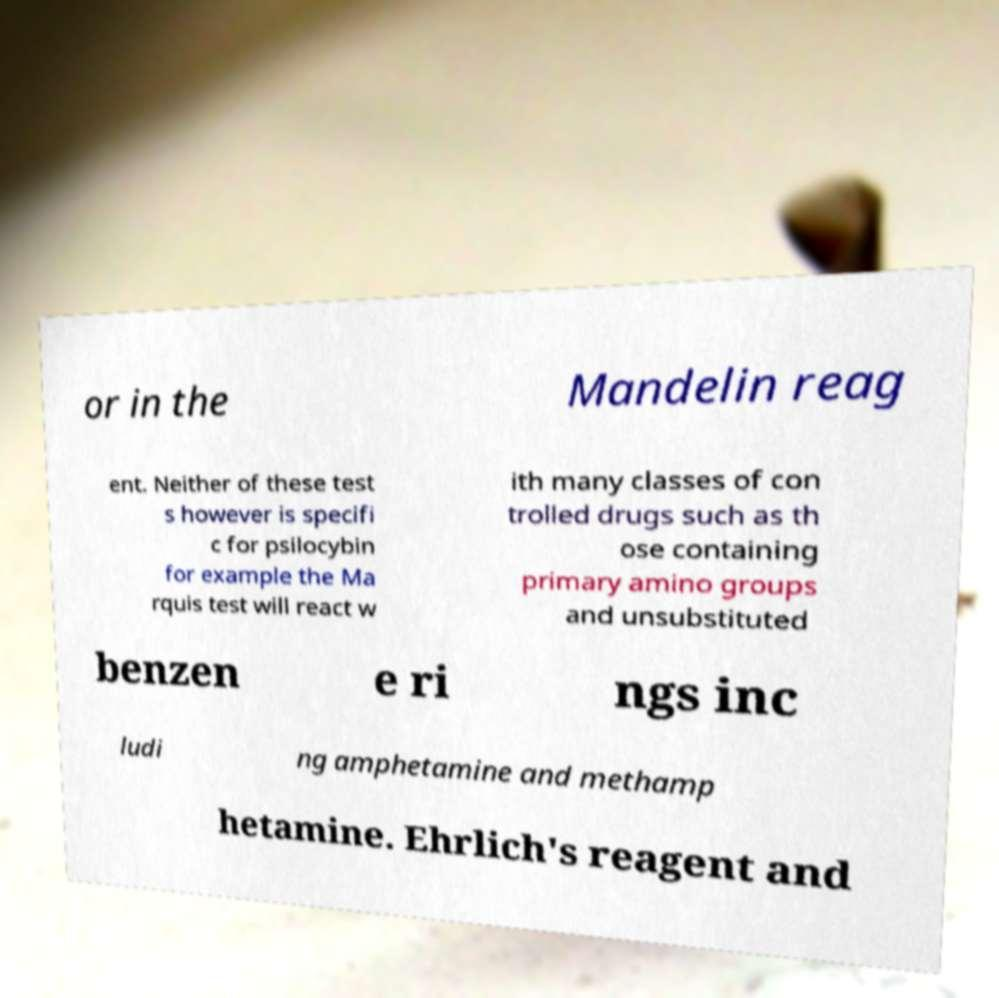Can you accurately transcribe the text from the provided image for me? or in the Mandelin reag ent. Neither of these test s however is specifi c for psilocybin for example the Ma rquis test will react w ith many classes of con trolled drugs such as th ose containing primary amino groups and unsubstituted benzen e ri ngs inc ludi ng amphetamine and methamp hetamine. Ehrlich's reagent and 